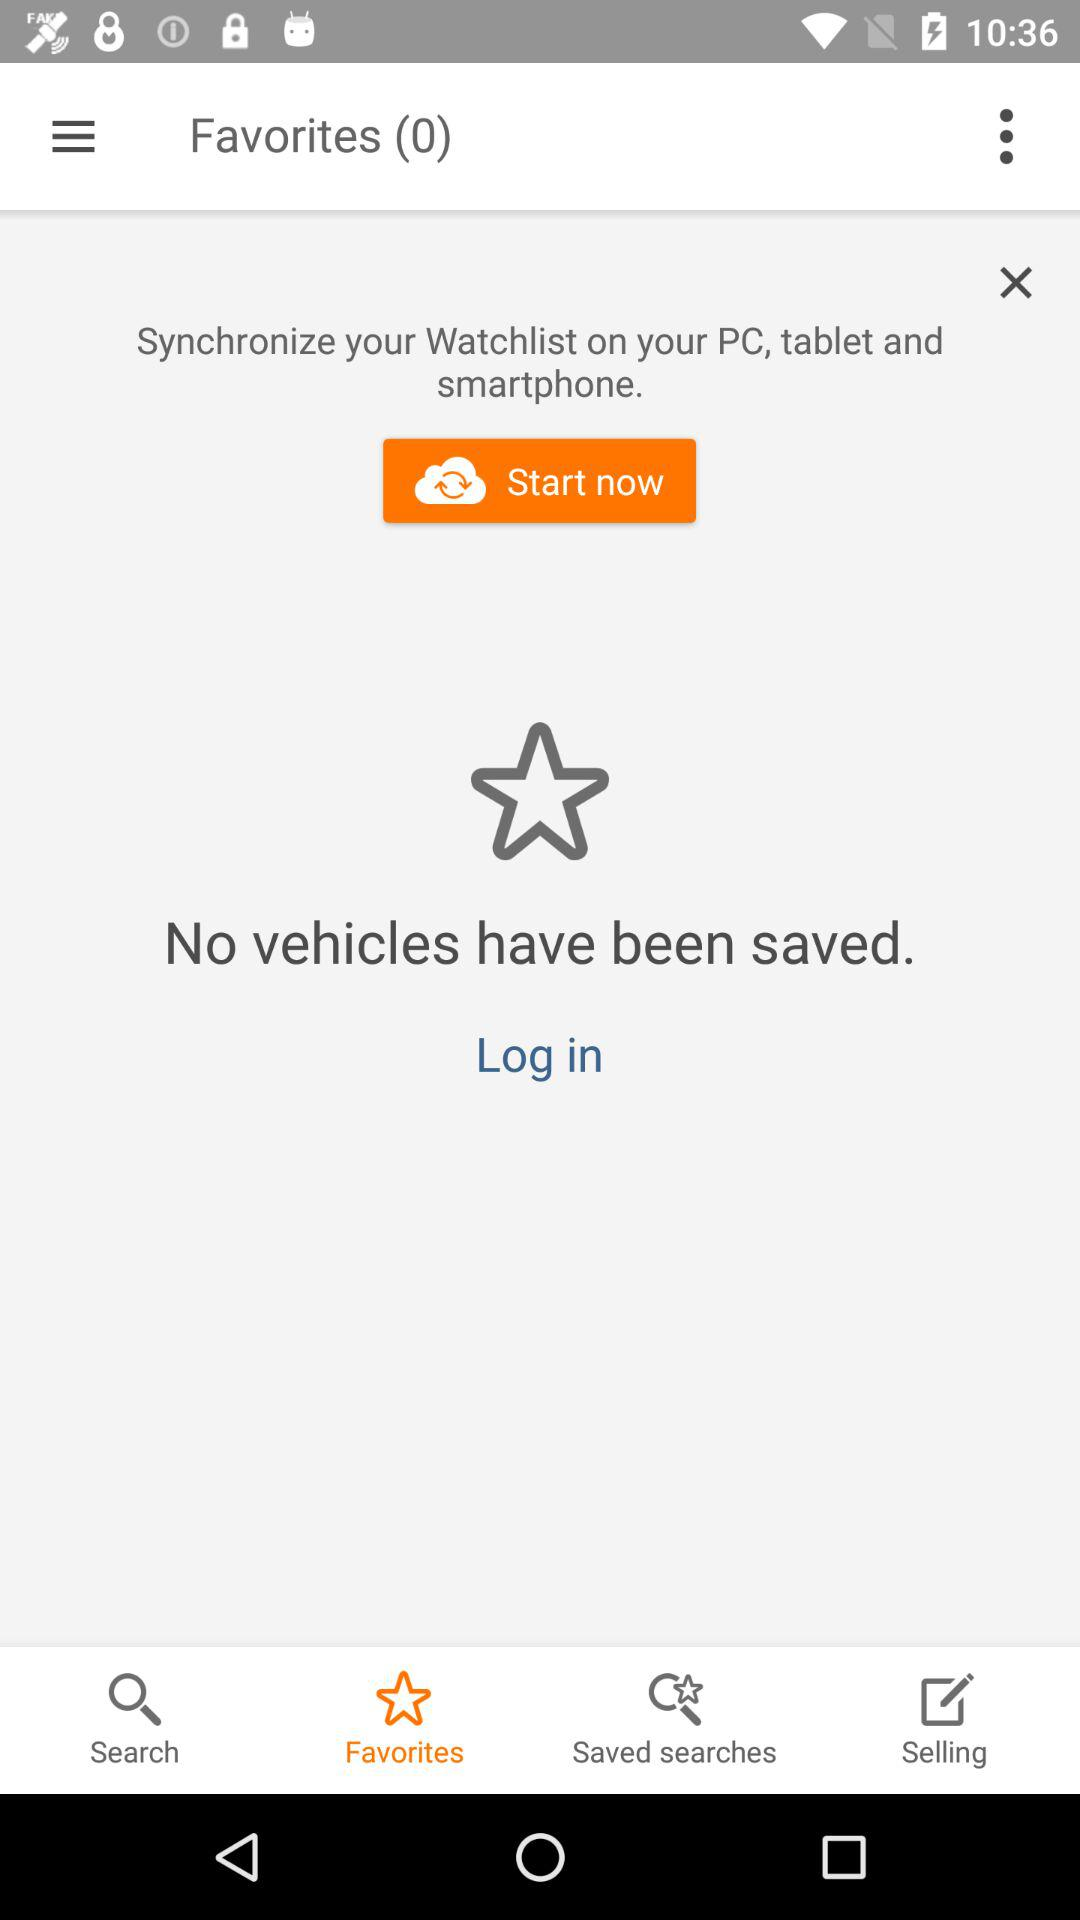How many vehicles have been saved?
Answer the question using a single word or phrase. 0 